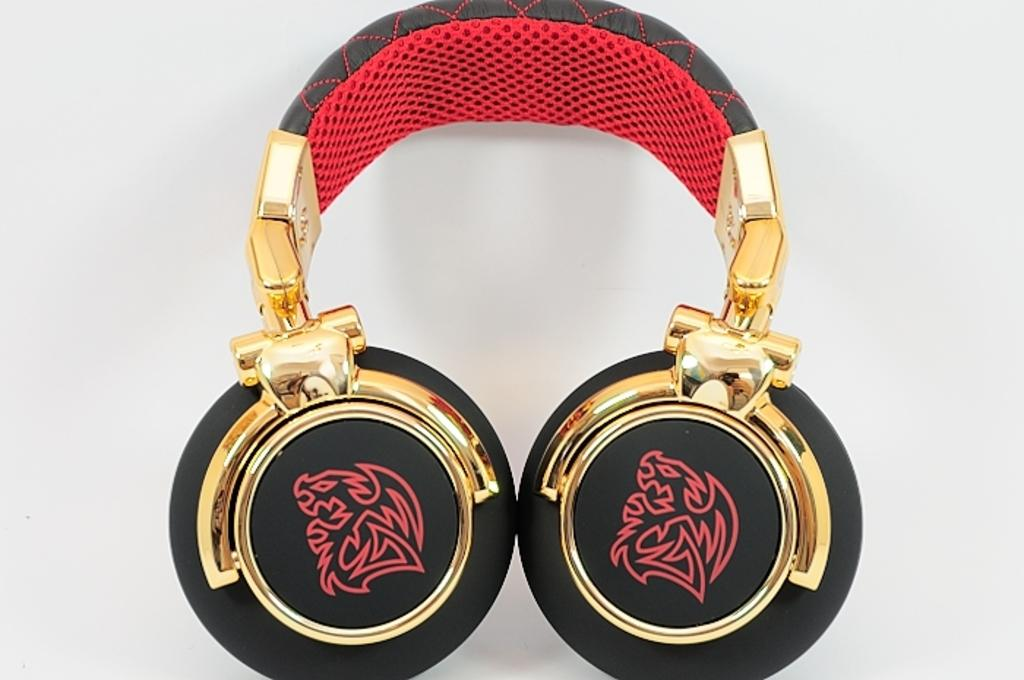What is the main object in the center of the image? There is a headset in the center of the image. What color is the headset? The headset is red in color. What type of cream is being used to treat the disease in the image? There is no cream or disease present in the image; it only features a red headset. 